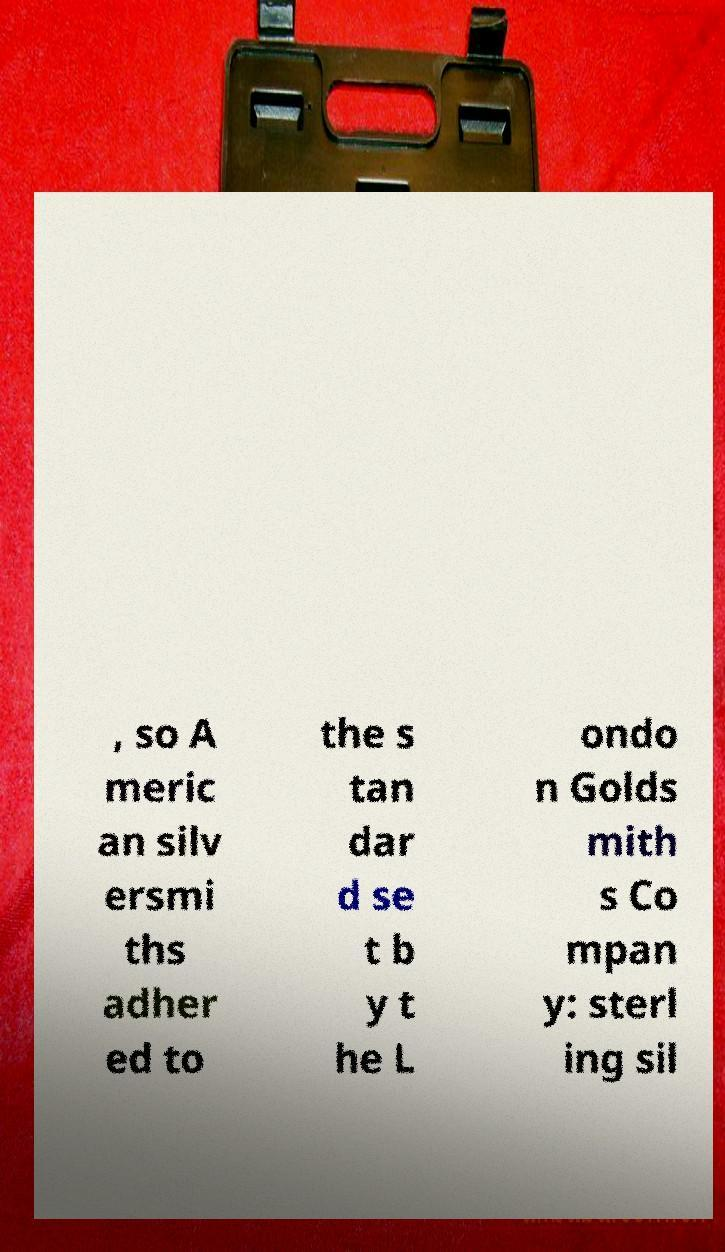Can you accurately transcribe the text from the provided image for me? , so A meric an silv ersmi ths adher ed to the s tan dar d se t b y t he L ondo n Golds mith s Co mpan y: sterl ing sil 